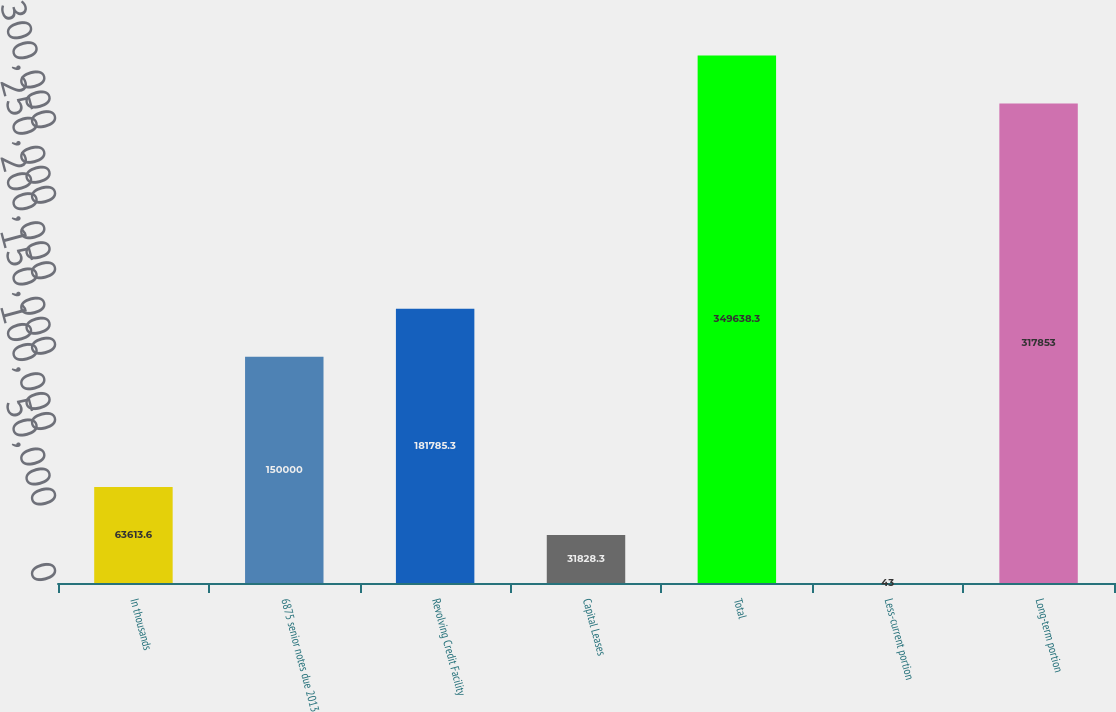Convert chart to OTSL. <chart><loc_0><loc_0><loc_500><loc_500><bar_chart><fcel>In thousands<fcel>6875 senior notes due 2013<fcel>Revolving Credit Facility<fcel>Capital Leases<fcel>Total<fcel>Less-current portion<fcel>Long-term portion<nl><fcel>63613.6<fcel>150000<fcel>181785<fcel>31828.3<fcel>349638<fcel>43<fcel>317853<nl></chart> 